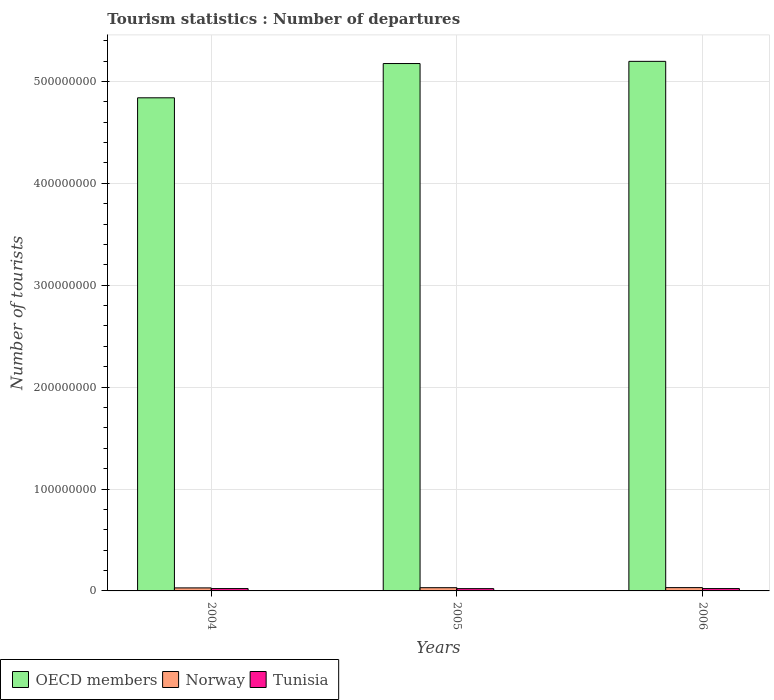How many groups of bars are there?
Keep it short and to the point. 3. Are the number of bars per tick equal to the number of legend labels?
Your answer should be compact. Yes. Are the number of bars on each tick of the X-axis equal?
Offer a terse response. Yes. How many bars are there on the 1st tick from the right?
Give a very brief answer. 3. In how many cases, is the number of bars for a given year not equal to the number of legend labels?
Make the answer very short. 0. What is the number of tourist departures in OECD members in 2006?
Your answer should be very brief. 5.20e+08. Across all years, what is the maximum number of tourist departures in OECD members?
Offer a very short reply. 5.20e+08. Across all years, what is the minimum number of tourist departures in OECD members?
Provide a succinct answer. 4.84e+08. In which year was the number of tourist departures in Tunisia maximum?
Give a very brief answer. 2004. What is the total number of tourist departures in Tunisia in the graph?
Your answer should be very brief. 6.86e+06. What is the difference between the number of tourist departures in Norway in 2005 and that in 2006?
Ensure brevity in your answer.  -7.00e+04. What is the difference between the number of tourist departures in Norway in 2005 and the number of tourist departures in Tunisia in 2004?
Make the answer very short. 8.54e+05. What is the average number of tourist departures in Norway per year?
Your response must be concise. 3.12e+06. In the year 2004, what is the difference between the number of tourist departures in Tunisia and number of tourist departures in OECD members?
Your answer should be very brief. -4.82e+08. In how many years, is the number of tourist departures in Norway greater than 140000000?
Give a very brief answer. 0. What is the ratio of the number of tourist departures in Tunisia in 2004 to that in 2005?
Ensure brevity in your answer.  1.03. Is the difference between the number of tourist departures in Tunisia in 2004 and 2005 greater than the difference between the number of tourist departures in OECD members in 2004 and 2005?
Provide a succinct answer. Yes. What is the difference between the highest and the lowest number of tourist departures in OECD members?
Give a very brief answer. 3.58e+07. What does the 2nd bar from the right in 2004 represents?
Offer a terse response. Norway. Are all the bars in the graph horizontal?
Your response must be concise. No. What is the difference between two consecutive major ticks on the Y-axis?
Your response must be concise. 1.00e+08. Does the graph contain grids?
Provide a succinct answer. Yes. Where does the legend appear in the graph?
Keep it short and to the point. Bottom left. What is the title of the graph?
Offer a very short reply. Tourism statistics : Number of departures. What is the label or title of the Y-axis?
Your answer should be very brief. Number of tourists. What is the Number of tourists in OECD members in 2004?
Provide a succinct answer. 4.84e+08. What is the Number of tourists of Norway in 2004?
Offer a very short reply. 2.96e+06. What is the Number of tourists of Tunisia in 2004?
Provide a short and direct response. 2.31e+06. What is the Number of tourists of OECD members in 2005?
Your response must be concise. 5.18e+08. What is the Number of tourists in Norway in 2005?
Your answer should be very brief. 3.17e+06. What is the Number of tourists in Tunisia in 2005?
Make the answer very short. 2.24e+06. What is the Number of tourists of OECD members in 2006?
Provide a short and direct response. 5.20e+08. What is the Number of tourists of Norway in 2006?
Your answer should be compact. 3.24e+06. What is the Number of tourists of Tunisia in 2006?
Offer a terse response. 2.30e+06. Across all years, what is the maximum Number of tourists in OECD members?
Provide a short and direct response. 5.20e+08. Across all years, what is the maximum Number of tourists in Norway?
Provide a succinct answer. 3.24e+06. Across all years, what is the maximum Number of tourists in Tunisia?
Your answer should be compact. 2.31e+06. Across all years, what is the minimum Number of tourists of OECD members?
Ensure brevity in your answer.  4.84e+08. Across all years, what is the minimum Number of tourists in Norway?
Make the answer very short. 2.96e+06. Across all years, what is the minimum Number of tourists of Tunisia?
Provide a succinct answer. 2.24e+06. What is the total Number of tourists in OECD members in the graph?
Offer a very short reply. 1.52e+09. What is the total Number of tourists in Norway in the graph?
Offer a terse response. 9.36e+06. What is the total Number of tourists in Tunisia in the graph?
Offer a very short reply. 6.86e+06. What is the difference between the Number of tourists of OECD members in 2004 and that in 2005?
Offer a terse response. -3.36e+07. What is the difference between the Number of tourists of Norway in 2004 and that in 2005?
Ensure brevity in your answer.  -2.06e+05. What is the difference between the Number of tourists of Tunisia in 2004 and that in 2005?
Provide a short and direct response. 7.10e+04. What is the difference between the Number of tourists in OECD members in 2004 and that in 2006?
Ensure brevity in your answer.  -3.58e+07. What is the difference between the Number of tourists of Norway in 2004 and that in 2006?
Provide a short and direct response. -2.76e+05. What is the difference between the Number of tourists in Tunisia in 2004 and that in 2006?
Offer a very short reply. 10000. What is the difference between the Number of tourists in OECD members in 2005 and that in 2006?
Your answer should be compact. -2.15e+06. What is the difference between the Number of tourists of Norway in 2005 and that in 2006?
Your response must be concise. -7.00e+04. What is the difference between the Number of tourists in Tunisia in 2005 and that in 2006?
Provide a short and direct response. -6.10e+04. What is the difference between the Number of tourists in OECD members in 2004 and the Number of tourists in Norway in 2005?
Provide a succinct answer. 4.81e+08. What is the difference between the Number of tourists of OECD members in 2004 and the Number of tourists of Tunisia in 2005?
Ensure brevity in your answer.  4.82e+08. What is the difference between the Number of tourists of Norway in 2004 and the Number of tourists of Tunisia in 2005?
Your response must be concise. 7.19e+05. What is the difference between the Number of tourists of OECD members in 2004 and the Number of tourists of Norway in 2006?
Offer a terse response. 4.81e+08. What is the difference between the Number of tourists in OECD members in 2004 and the Number of tourists in Tunisia in 2006?
Keep it short and to the point. 4.82e+08. What is the difference between the Number of tourists of Norway in 2004 and the Number of tourists of Tunisia in 2006?
Ensure brevity in your answer.  6.58e+05. What is the difference between the Number of tourists of OECD members in 2005 and the Number of tourists of Norway in 2006?
Give a very brief answer. 5.14e+08. What is the difference between the Number of tourists in OECD members in 2005 and the Number of tourists in Tunisia in 2006?
Offer a very short reply. 5.15e+08. What is the difference between the Number of tourists in Norway in 2005 and the Number of tourists in Tunisia in 2006?
Your response must be concise. 8.64e+05. What is the average Number of tourists of OECD members per year?
Your answer should be compact. 5.07e+08. What is the average Number of tourists of Norway per year?
Ensure brevity in your answer.  3.12e+06. What is the average Number of tourists in Tunisia per year?
Offer a terse response. 2.28e+06. In the year 2004, what is the difference between the Number of tourists in OECD members and Number of tourists in Norway?
Offer a very short reply. 4.81e+08. In the year 2004, what is the difference between the Number of tourists of OECD members and Number of tourists of Tunisia?
Provide a succinct answer. 4.82e+08. In the year 2004, what is the difference between the Number of tourists of Norway and Number of tourists of Tunisia?
Your answer should be compact. 6.48e+05. In the year 2005, what is the difference between the Number of tourists in OECD members and Number of tourists in Norway?
Keep it short and to the point. 5.14e+08. In the year 2005, what is the difference between the Number of tourists of OECD members and Number of tourists of Tunisia?
Your response must be concise. 5.15e+08. In the year 2005, what is the difference between the Number of tourists in Norway and Number of tourists in Tunisia?
Your answer should be very brief. 9.25e+05. In the year 2006, what is the difference between the Number of tourists of OECD members and Number of tourists of Norway?
Give a very brief answer. 5.16e+08. In the year 2006, what is the difference between the Number of tourists of OECD members and Number of tourists of Tunisia?
Your answer should be very brief. 5.17e+08. In the year 2006, what is the difference between the Number of tourists of Norway and Number of tourists of Tunisia?
Your answer should be very brief. 9.34e+05. What is the ratio of the Number of tourists of OECD members in 2004 to that in 2005?
Your answer should be very brief. 0.94. What is the ratio of the Number of tourists of Norway in 2004 to that in 2005?
Offer a very short reply. 0.93. What is the ratio of the Number of tourists in Tunisia in 2004 to that in 2005?
Give a very brief answer. 1.03. What is the ratio of the Number of tourists in OECD members in 2004 to that in 2006?
Provide a succinct answer. 0.93. What is the ratio of the Number of tourists of Norway in 2004 to that in 2006?
Keep it short and to the point. 0.91. What is the ratio of the Number of tourists of Tunisia in 2004 to that in 2006?
Ensure brevity in your answer.  1. What is the ratio of the Number of tourists in Norway in 2005 to that in 2006?
Provide a succinct answer. 0.98. What is the ratio of the Number of tourists in Tunisia in 2005 to that in 2006?
Your response must be concise. 0.97. What is the difference between the highest and the second highest Number of tourists in OECD members?
Provide a short and direct response. 2.15e+06. What is the difference between the highest and the second highest Number of tourists in Norway?
Ensure brevity in your answer.  7.00e+04. What is the difference between the highest and the second highest Number of tourists in Tunisia?
Give a very brief answer. 10000. What is the difference between the highest and the lowest Number of tourists in OECD members?
Your answer should be compact. 3.58e+07. What is the difference between the highest and the lowest Number of tourists in Norway?
Provide a short and direct response. 2.76e+05. What is the difference between the highest and the lowest Number of tourists in Tunisia?
Keep it short and to the point. 7.10e+04. 